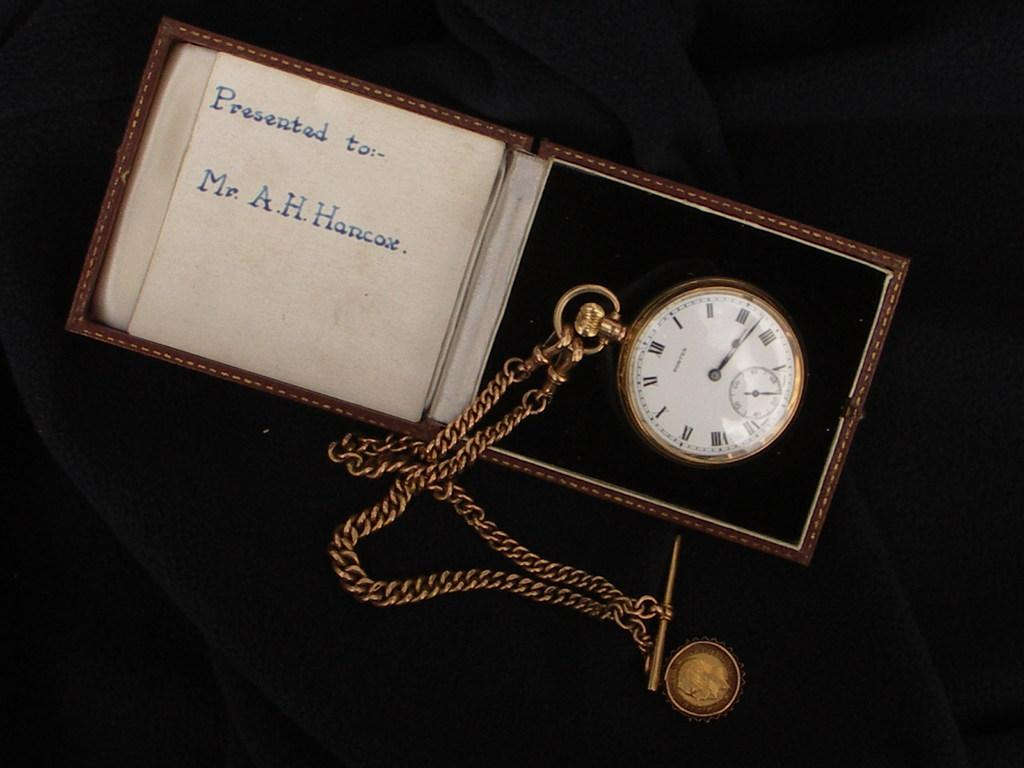<image>
Share a concise interpretation of the image provided. Pocket watch sits in its case it was presented to Mr. A.H.Hancox. 